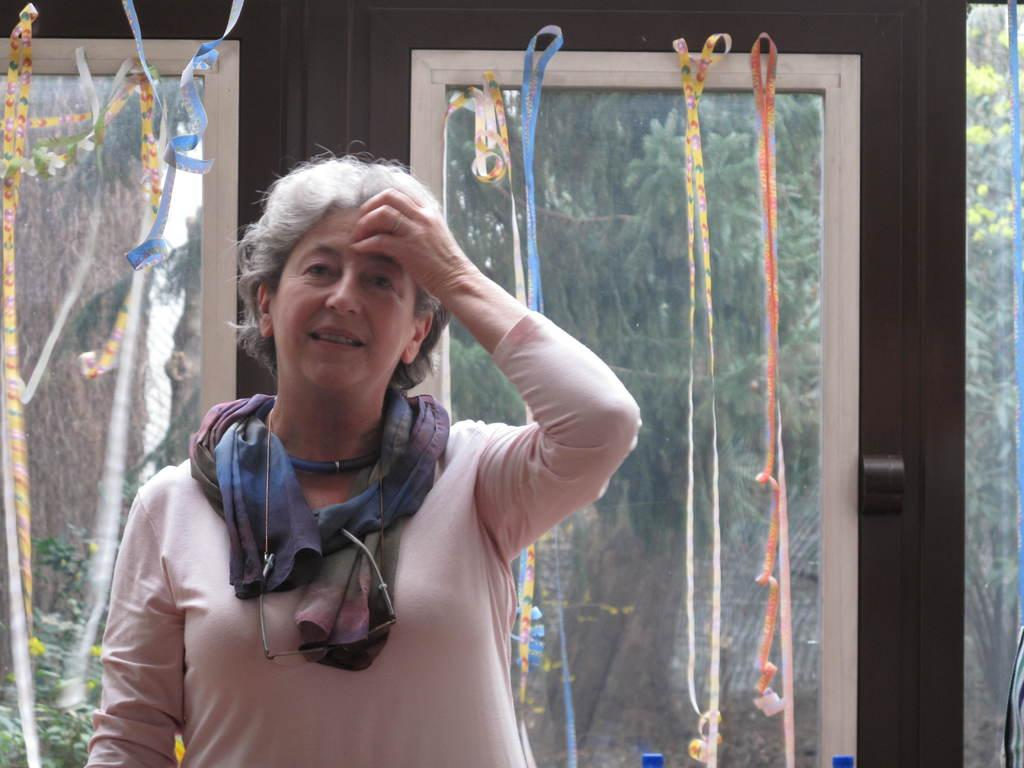Who is present in the image? There is a woman in the image. What is the woman wearing? The woman is wearing clothes and a scarf. What is the woman's facial expression? The woman is smiling. What objects can be seen in the image? There are spectacles and ribbons in the image. What can be seen through the windows in the image? Trees are visible through the windows. What hobbies does the goose have, as seen in the image? There is no goose present in the image, so we cannot determine its hobbies. What time of day is it in the image, based on the woman's morning routine? The provided facts do not mention a morning routine or the time of day, so we cannot determine when the image takes place. 